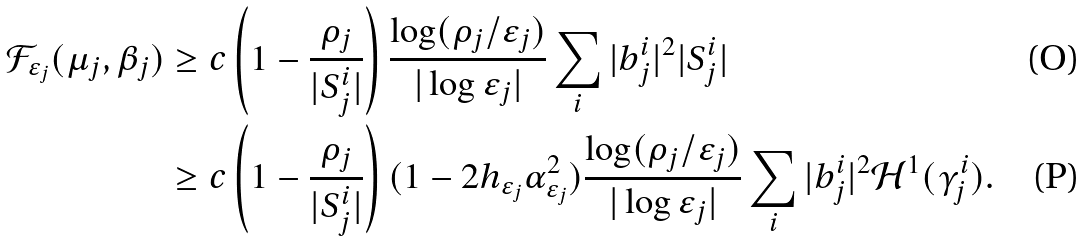Convert formula to latex. <formula><loc_0><loc_0><loc_500><loc_500>\mathcal { F } _ { \varepsilon _ { j } } ( \mu _ { j } , \beta _ { j } ) & \geq c \left ( 1 - \frac { \rho _ { j } } { | S _ { j } ^ { i } | } \right ) \frac { \log ( \rho _ { j } / \varepsilon _ { j } ) } { | \log \varepsilon _ { j } | } \sum _ { i } | b _ { j } ^ { i } | ^ { 2 } | S _ { j } ^ { i } | \\ & \geq c \left ( 1 - \frac { \rho _ { j } } { | S _ { j } ^ { i } | } \right ) ( 1 - 2 h _ { \varepsilon _ { j } } \alpha _ { \varepsilon _ { j } } ^ { 2 } ) \frac { \log ( \rho _ { j } / \varepsilon _ { j } ) } { | \log \varepsilon _ { j } | } \sum _ { i } | b _ { j } ^ { i } | ^ { 2 } \mathcal { H } ^ { 1 } ( \gamma _ { j } ^ { i } ) .</formula> 